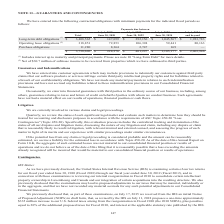According to Opentext Corporation's financial document, What does the table represent? contractual obligations with minimum payments for the indicated fiscal periods. The document states: "We have entered into the following contractual obligations with minimum payments for the indicated fiscal periods as follows:..." Also, What is Operating lease obligations net of? $30.7 million of sublease income. The document states: "(2) Net of $30.7 million of sublease income to be received from properties which we have subleased to third parties...." Also, What does Long-term debt obligations include? interest up to maturity and principal payments. The document states: "(1) Includes interest up to maturity and principal payments. Please see note 10 "Long-Term Debt" for more details...." Also, can you calculate: What is the Total Operating lease obligations expressed as a percentage of Total obligations? Based on the calculation: 318,851/3,738,696, the result is 8.53 (percentage). This is based on the information: "5,567 $ 1,923,783 Operating lease obligations (2) 318,851 72,853 106,394 59,441 80,163 Purchase obligations 11,280 8,364 2,747 169 — $ 3,738,696 $ 228,276 $ 3 Purchase obligations 11,280 8,364 2,747 1..." The key data points involved are: 3,738,696, 318,851. Additionally, In what year range(s) are Operating lease obligations more than $100,000(in thousands)? July 1, 2020— June 30, 2022. The document states: "Total July 1, 2019— June 30, 2020 July 1, 2020— June 30, 2022 July 1, 2022— June 30, 2024 July 1, 2024 and beyond Long-term debt obligations (1) $ 3,4..." Also, can you calculate: What is the total obligations of July 1, 2024 and beyond expressed as a percentage of total obligations for July 1, 2019-June 30, 2024? To answer this question, I need to perform calculations using the financial data. The calculation is: 2,003,946/(3,738,696-2,003,946), which equals 115.52 (percentage). This is based on the information: "9 — $ 3,738,696 $ 228,276 $ 401,297 $ 1,105,177 $ 2,003,946 3 Purchase obligations 11,280 8,364 2,747 169 — $ 3,738,696 $ 228,276 $ 401,297 $ 1,105,177 $ 2,003,946..." The key data points involved are: 2,003,946, 3,738,696. 